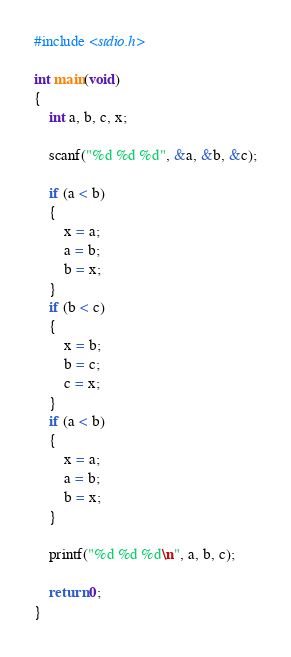<code> <loc_0><loc_0><loc_500><loc_500><_C_>#include <stdio.h>

int main(void)
{
    int a, b, c, x;
    
    scanf("%d %d %d", &a, &b, &c);
    
    if (a < b)
    {
        x = a;
        a = b;
        b = x;
    }
    if (b < c)
    {
        x = b;
        b = c;
        c = x;
    }
    if (a < b)
    {
        x = a;
        a = b;
        b = x;
    }
    
    printf("%d %d %d\n", a, b, c);
    
    return 0;
}</code> 